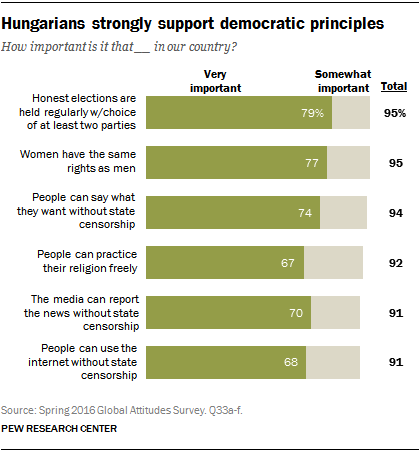Specify some key components in this picture. Of the options that over 70% of respondents consider to be very important, three options stand out. A survey shows that 77% of respondents believe it is very important for women to have the same rights as men. 